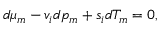Convert formula to latex. <formula><loc_0><loc_0><loc_500><loc_500>d \mu _ { m } - v _ { i } d p _ { m } + s _ { i } d T _ { m } = 0 ,</formula> 